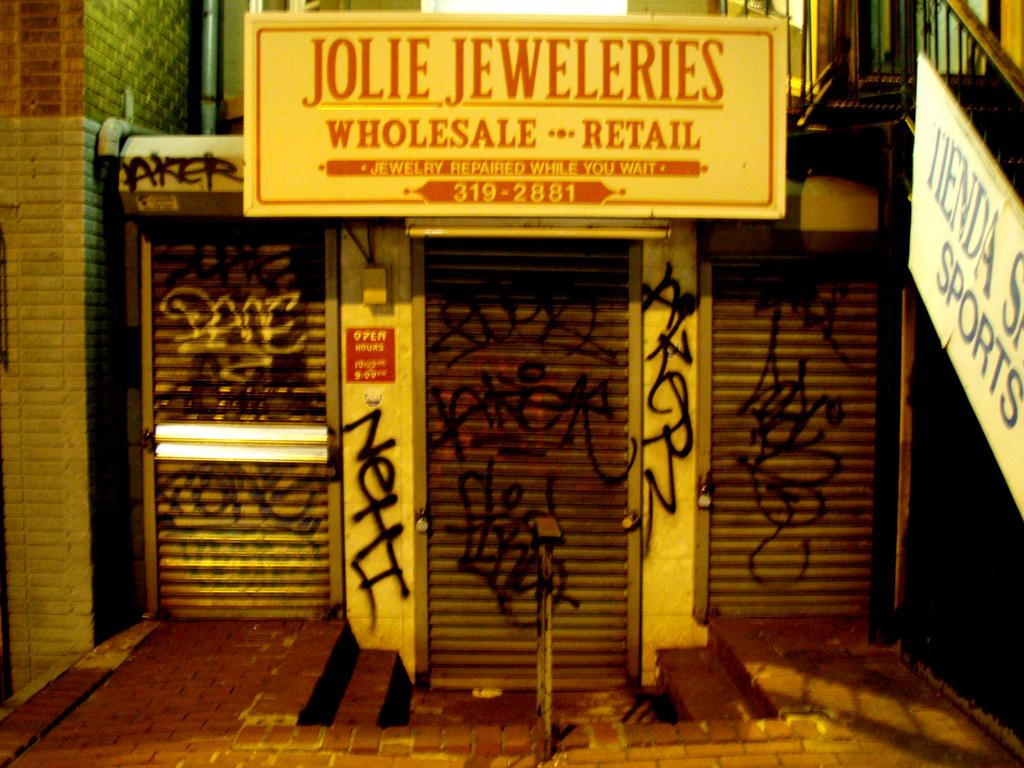<image>
Give a short and clear explanation of the subsequent image. Graffiti is on the walls below a sign for Jolie Jeweleries. 